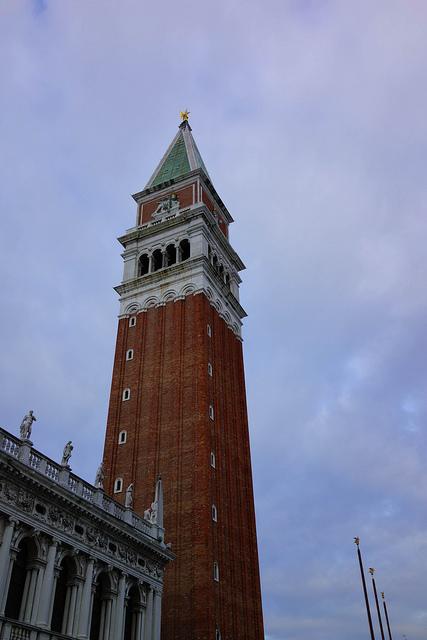What famous landmark is shown?
Answer briefly. Church. Are there clocks on this building?
Quick response, please. Yes. What famous landmark is this?
Short answer required. Big ben. Are there statues in this picture?
Answer briefly. Yes. Who works in this building?
Give a very brief answer. Government. What is there?
Keep it brief. Tower. Is there a clock in the tower?
Keep it brief. Yes. What could be hung on top of this tower?
Quick response, please. Clock. Is the building old?
Give a very brief answer. Yes. 